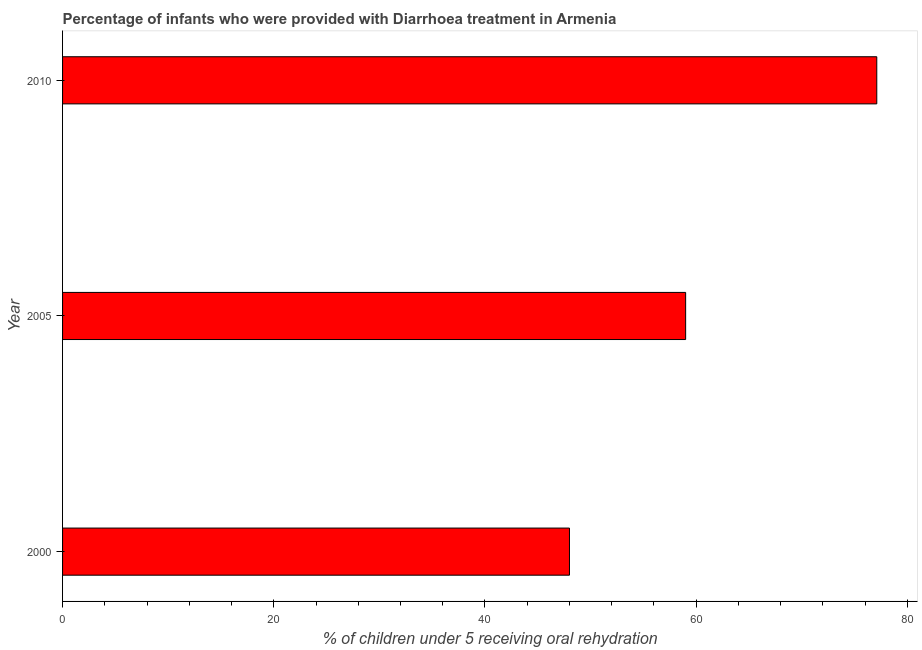Does the graph contain any zero values?
Offer a terse response. No. Does the graph contain grids?
Give a very brief answer. No. What is the title of the graph?
Give a very brief answer. Percentage of infants who were provided with Diarrhoea treatment in Armenia. What is the label or title of the X-axis?
Offer a terse response. % of children under 5 receiving oral rehydration. What is the label or title of the Y-axis?
Offer a terse response. Year. What is the percentage of children who were provided with treatment diarrhoea in 2010?
Your answer should be compact. 77.1. Across all years, what is the maximum percentage of children who were provided with treatment diarrhoea?
Your answer should be compact. 77.1. Across all years, what is the minimum percentage of children who were provided with treatment diarrhoea?
Provide a short and direct response. 48. In which year was the percentage of children who were provided with treatment diarrhoea maximum?
Offer a terse response. 2010. In which year was the percentage of children who were provided with treatment diarrhoea minimum?
Offer a terse response. 2000. What is the sum of the percentage of children who were provided with treatment diarrhoea?
Provide a succinct answer. 184.1. What is the difference between the percentage of children who were provided with treatment diarrhoea in 2000 and 2010?
Make the answer very short. -29.1. What is the average percentage of children who were provided with treatment diarrhoea per year?
Your answer should be very brief. 61.37. Do a majority of the years between 2000 and 2010 (inclusive) have percentage of children who were provided with treatment diarrhoea greater than 48 %?
Your answer should be very brief. Yes. What is the ratio of the percentage of children who were provided with treatment diarrhoea in 2000 to that in 2010?
Give a very brief answer. 0.62. Is the percentage of children who were provided with treatment diarrhoea in 2005 less than that in 2010?
Provide a succinct answer. Yes. Is the difference between the percentage of children who were provided with treatment diarrhoea in 2000 and 2010 greater than the difference between any two years?
Give a very brief answer. Yes. Is the sum of the percentage of children who were provided with treatment diarrhoea in 2005 and 2010 greater than the maximum percentage of children who were provided with treatment diarrhoea across all years?
Offer a very short reply. Yes. What is the difference between the highest and the lowest percentage of children who were provided with treatment diarrhoea?
Give a very brief answer. 29.1. In how many years, is the percentage of children who were provided with treatment diarrhoea greater than the average percentage of children who were provided with treatment diarrhoea taken over all years?
Provide a succinct answer. 1. How many bars are there?
Provide a short and direct response. 3. Are all the bars in the graph horizontal?
Give a very brief answer. Yes. Are the values on the major ticks of X-axis written in scientific E-notation?
Provide a short and direct response. No. What is the % of children under 5 receiving oral rehydration in 2000?
Make the answer very short. 48. What is the % of children under 5 receiving oral rehydration of 2010?
Offer a very short reply. 77.1. What is the difference between the % of children under 5 receiving oral rehydration in 2000 and 2005?
Your answer should be very brief. -11. What is the difference between the % of children under 5 receiving oral rehydration in 2000 and 2010?
Your answer should be compact. -29.1. What is the difference between the % of children under 5 receiving oral rehydration in 2005 and 2010?
Your answer should be compact. -18.1. What is the ratio of the % of children under 5 receiving oral rehydration in 2000 to that in 2005?
Provide a succinct answer. 0.81. What is the ratio of the % of children under 5 receiving oral rehydration in 2000 to that in 2010?
Provide a succinct answer. 0.62. What is the ratio of the % of children under 5 receiving oral rehydration in 2005 to that in 2010?
Offer a terse response. 0.77. 